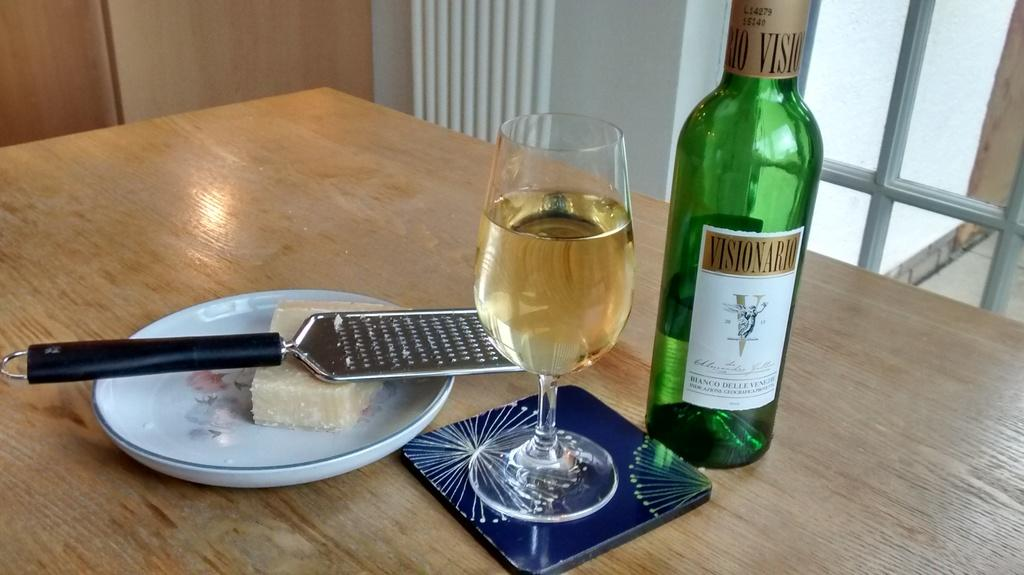What is on the plate that is visible in the image? There is food on the plate in the image. What utensil is visible in the image? There is a spoon in the image. What is in the glass that is visible in the image? There is a drink in the glass in the image. What other object is visible in the image? There is a bottle in the image. Where are the objects located in the image? The objects are on a table in the image. What can be seen in the background of the image? There is a wall and a glass window in the background of the image. How many dogs are visible in the image? There are no dogs present in the image. What type of shoe is on the table in the image? There is no shoe present in the image. 